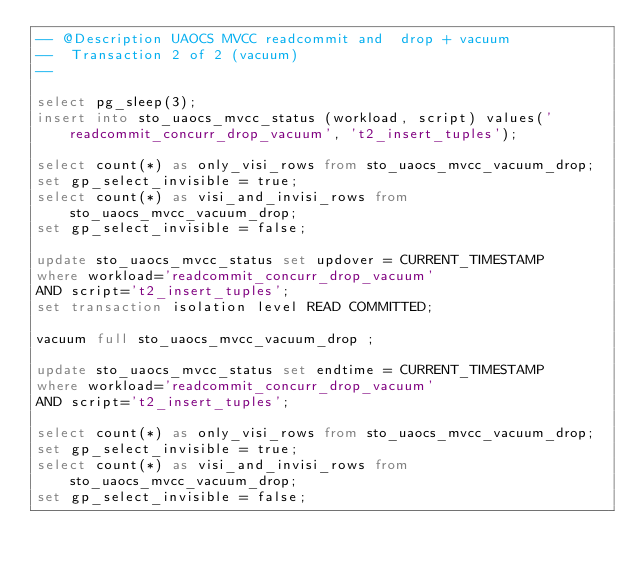<code> <loc_0><loc_0><loc_500><loc_500><_SQL_>-- @Description UAOCS MVCC readcommit and  drop + vacuum
--  Transaction 2 of 2 (vacuum)
-- 

select pg_sleep(3);
insert into sto_uaocs_mvcc_status (workload, script) values('readcommit_concurr_drop_vacuum', 't2_insert_tuples');

select count(*) as only_visi_rows from sto_uaocs_mvcc_vacuum_drop;
set gp_select_invisible = true;
select count(*) as visi_and_invisi_rows from sto_uaocs_mvcc_vacuum_drop;
set gp_select_invisible = false;

update sto_uaocs_mvcc_status set updover = CURRENT_TIMESTAMP 
where workload='readcommit_concurr_drop_vacuum' 
AND script='t2_insert_tuples';
set transaction isolation level READ COMMITTED;

vacuum full sto_uaocs_mvcc_vacuum_drop ;

update sto_uaocs_mvcc_status set endtime = CURRENT_TIMESTAMP 
where workload='readcommit_concurr_drop_vacuum' 
AND script='t2_insert_tuples';

select count(*) as only_visi_rows from sto_uaocs_mvcc_vacuum_drop;
set gp_select_invisible = true;
select count(*) as visi_and_invisi_rows from sto_uaocs_mvcc_vacuum_drop;
set gp_select_invisible = false;

</code> 